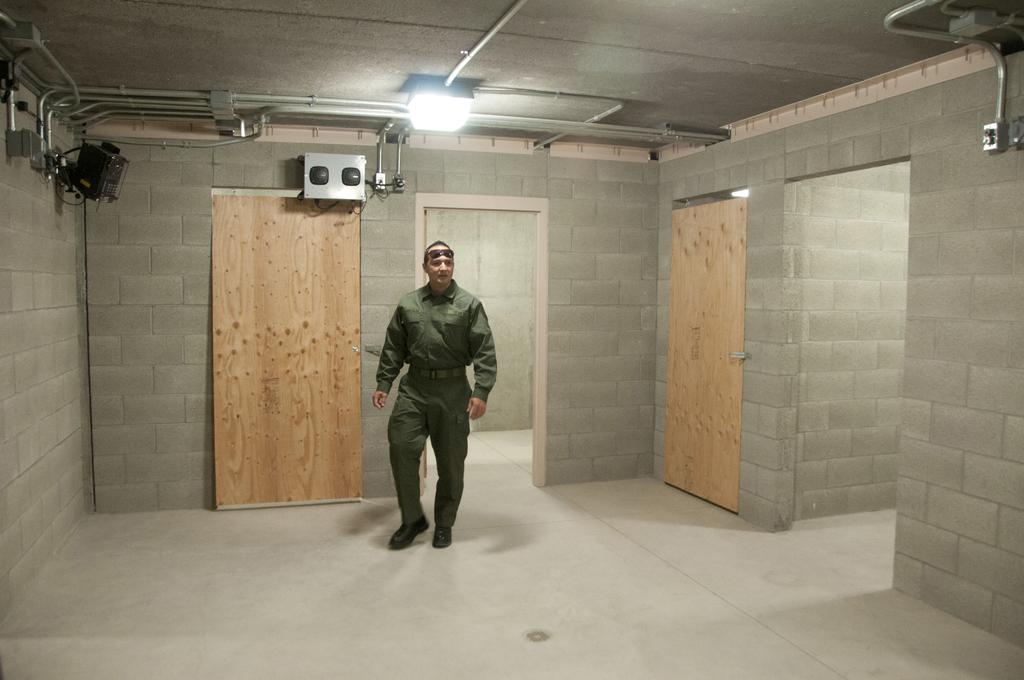What is the main subject of the image? There is a man standing in the image. Where is the man standing? The man is standing on the floor. What can be seen in the background of the image? Electric lights, pipelines, electric shafts, and a camera are present in the background of the image. What type of rice is being cooked in the image? There is no rice present in the image. What type of cloud can be seen in the background of the image? There are no clouds visible in the image; it is an indoor setting with electric lights and other industrial elements. 